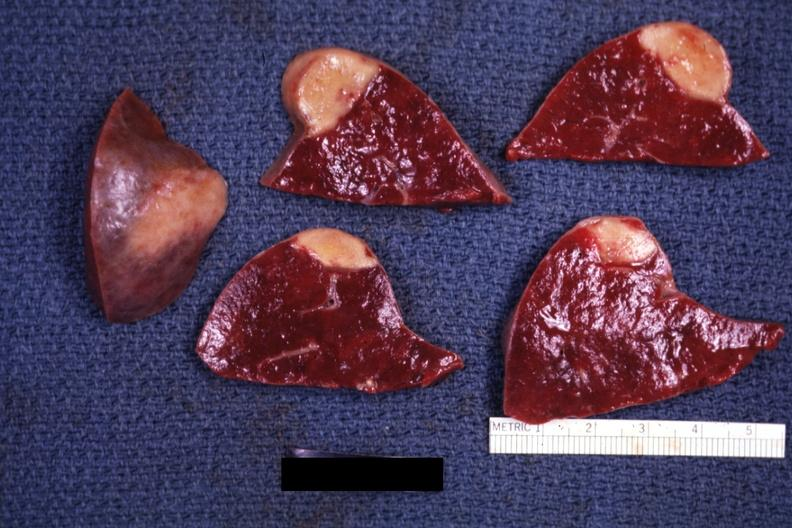what is present?
Answer the question using a single word or phrase. Infarct 